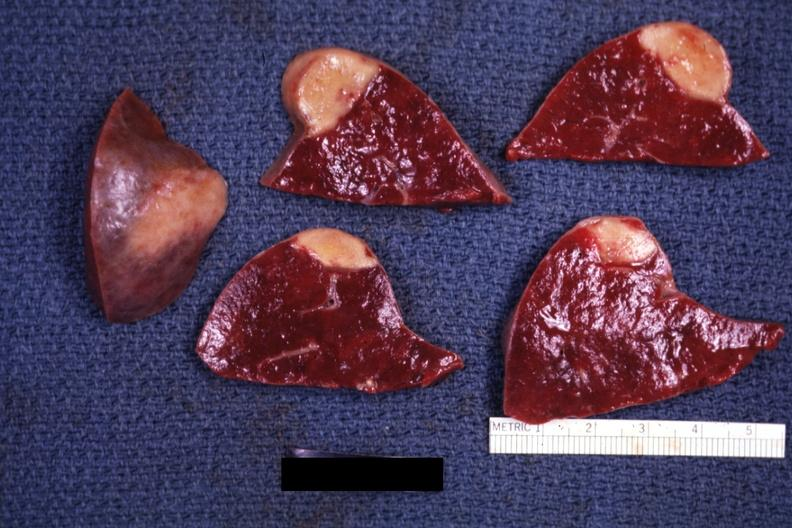what is present?
Answer the question using a single word or phrase. Infarct 